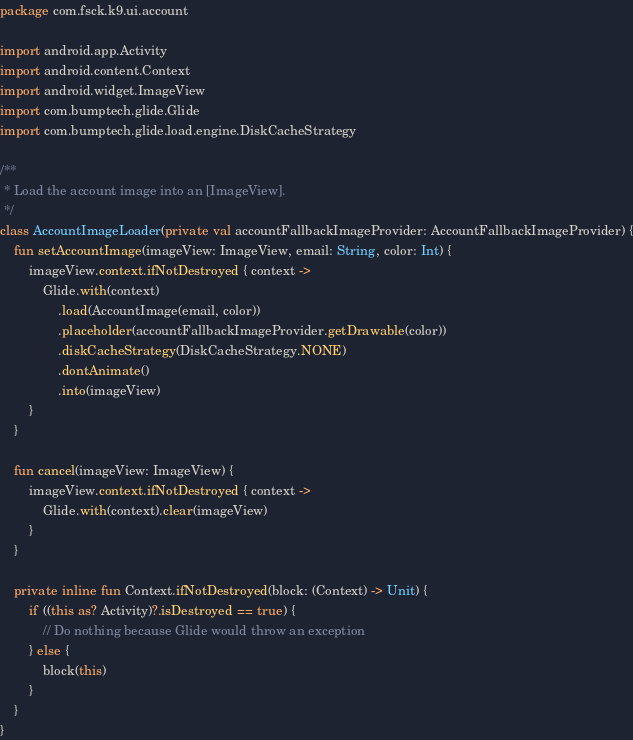<code> <loc_0><loc_0><loc_500><loc_500><_Kotlin_>package com.fsck.k9.ui.account

import android.app.Activity
import android.content.Context
import android.widget.ImageView
import com.bumptech.glide.Glide
import com.bumptech.glide.load.engine.DiskCacheStrategy

/**
 * Load the account image into an [ImageView].
 */
class AccountImageLoader(private val accountFallbackImageProvider: AccountFallbackImageProvider) {
    fun setAccountImage(imageView: ImageView, email: String, color: Int) {
        imageView.context.ifNotDestroyed { context ->
            Glide.with(context)
                .load(AccountImage(email, color))
                .placeholder(accountFallbackImageProvider.getDrawable(color))
                .diskCacheStrategy(DiskCacheStrategy.NONE)
                .dontAnimate()
                .into(imageView)
        }
    }

    fun cancel(imageView: ImageView) {
        imageView.context.ifNotDestroyed { context ->
            Glide.with(context).clear(imageView)
        }
    }

    private inline fun Context.ifNotDestroyed(block: (Context) -> Unit) {
        if ((this as? Activity)?.isDestroyed == true) {
            // Do nothing because Glide would throw an exception
        } else {
            block(this)
        }
    }
}
</code> 